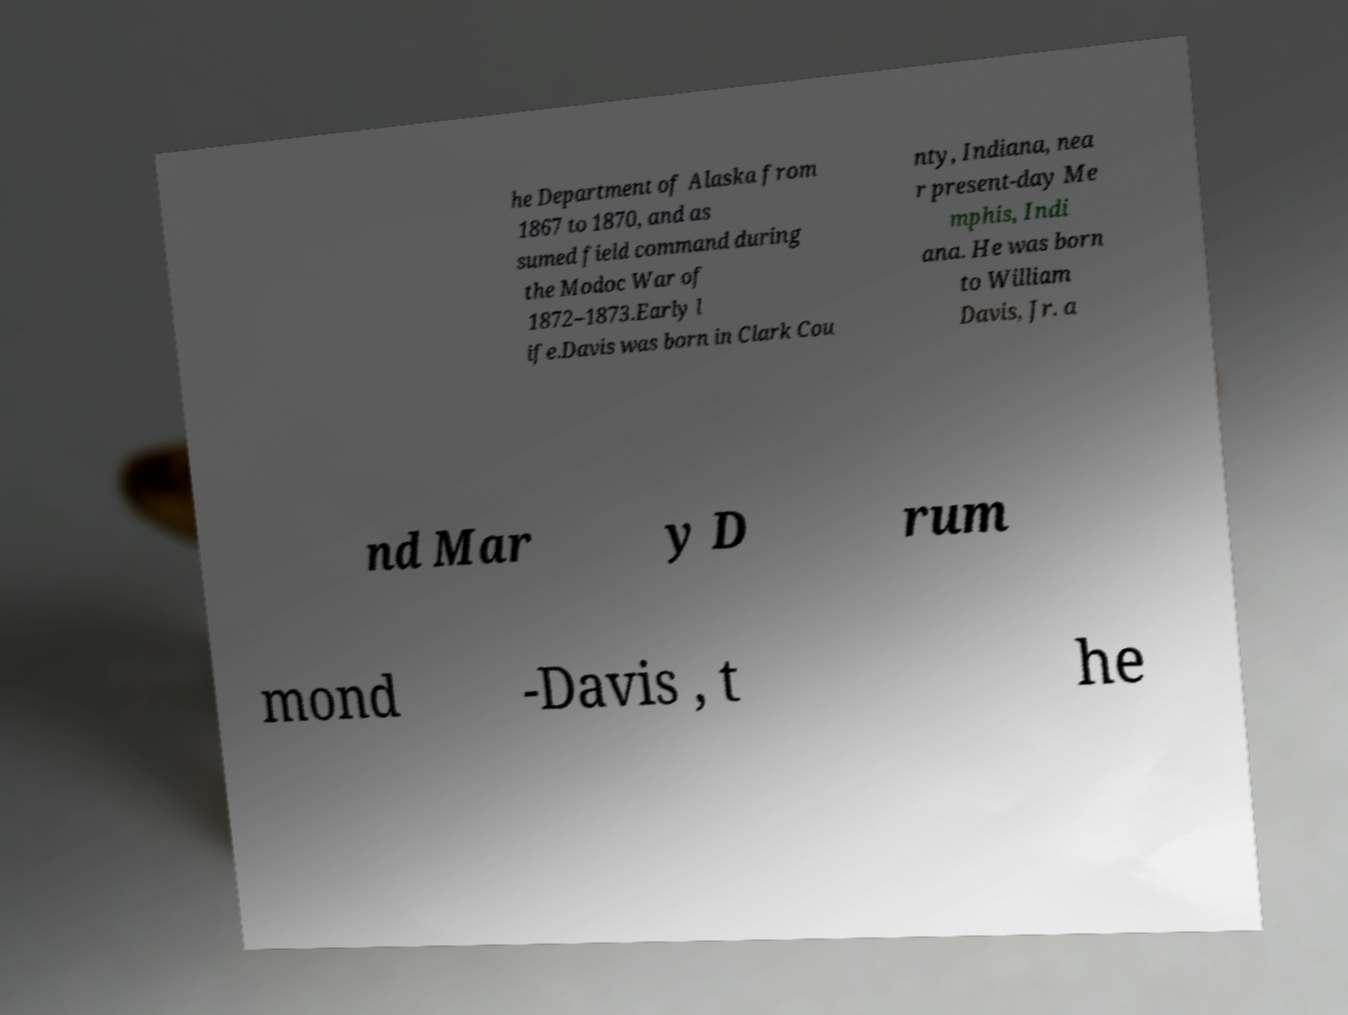What messages or text are displayed in this image? I need them in a readable, typed format. he Department of Alaska from 1867 to 1870, and as sumed field command during the Modoc War of 1872–1873.Early l ife.Davis was born in Clark Cou nty, Indiana, nea r present-day Me mphis, Indi ana. He was born to William Davis, Jr. a nd Mar y D rum mond -Davis , t he 